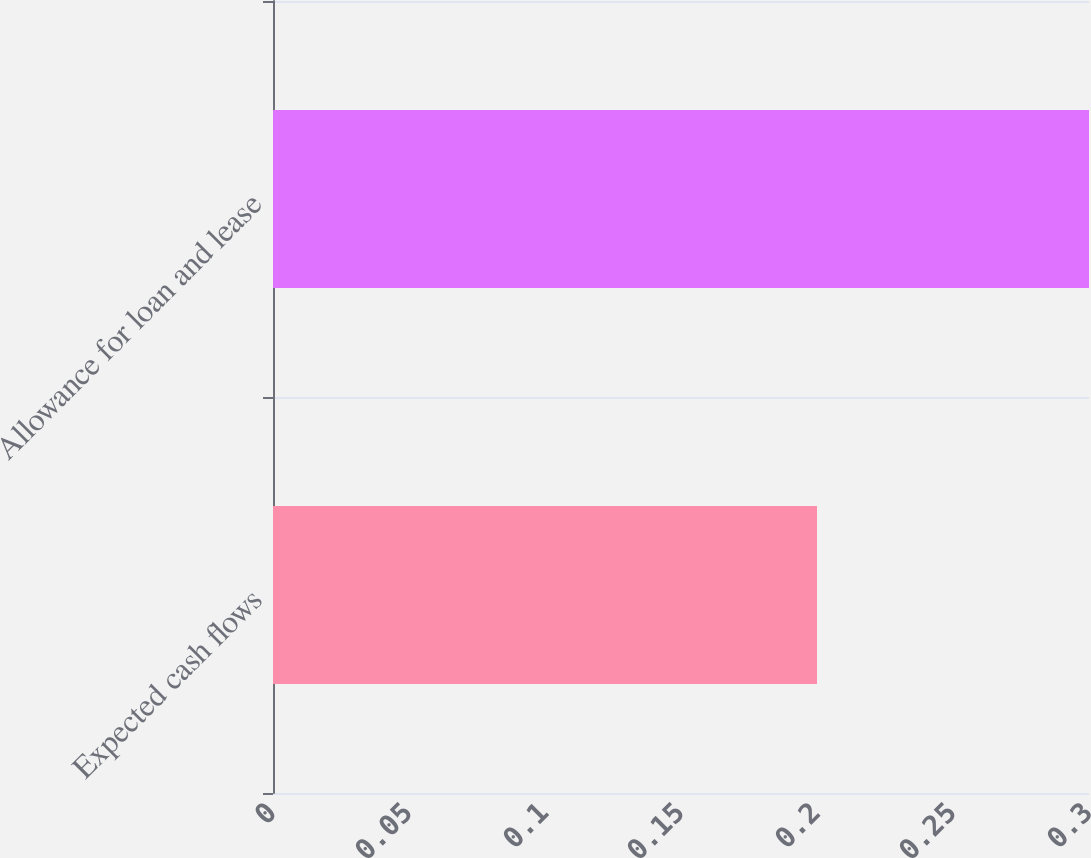Convert chart. <chart><loc_0><loc_0><loc_500><loc_500><bar_chart><fcel>Expected cash flows<fcel>Allowance for loan and lease<nl><fcel>0.2<fcel>0.3<nl></chart> 